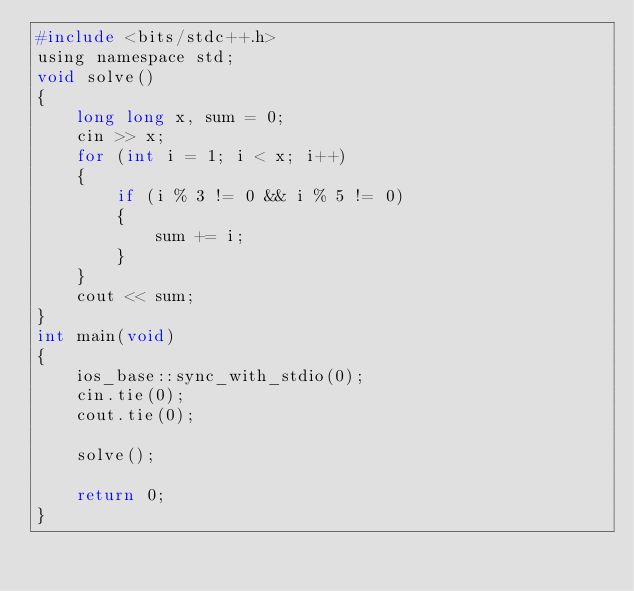Convert code to text. <code><loc_0><loc_0><loc_500><loc_500><_C_>#include <bits/stdc++.h>
using namespace std;
void solve()
{
	long long x, sum = 0;
	cin >> x;
	for (int i = 1; i < x; i++)
	{
		if (i % 3 != 0 && i % 5 != 0)
		{
			sum += i;
		}
	}
	cout << sum;
}
int main(void)
{
	ios_base::sync_with_stdio(0);
	cin.tie(0);
	cout.tie(0);

	solve();

	return 0;
}
</code> 